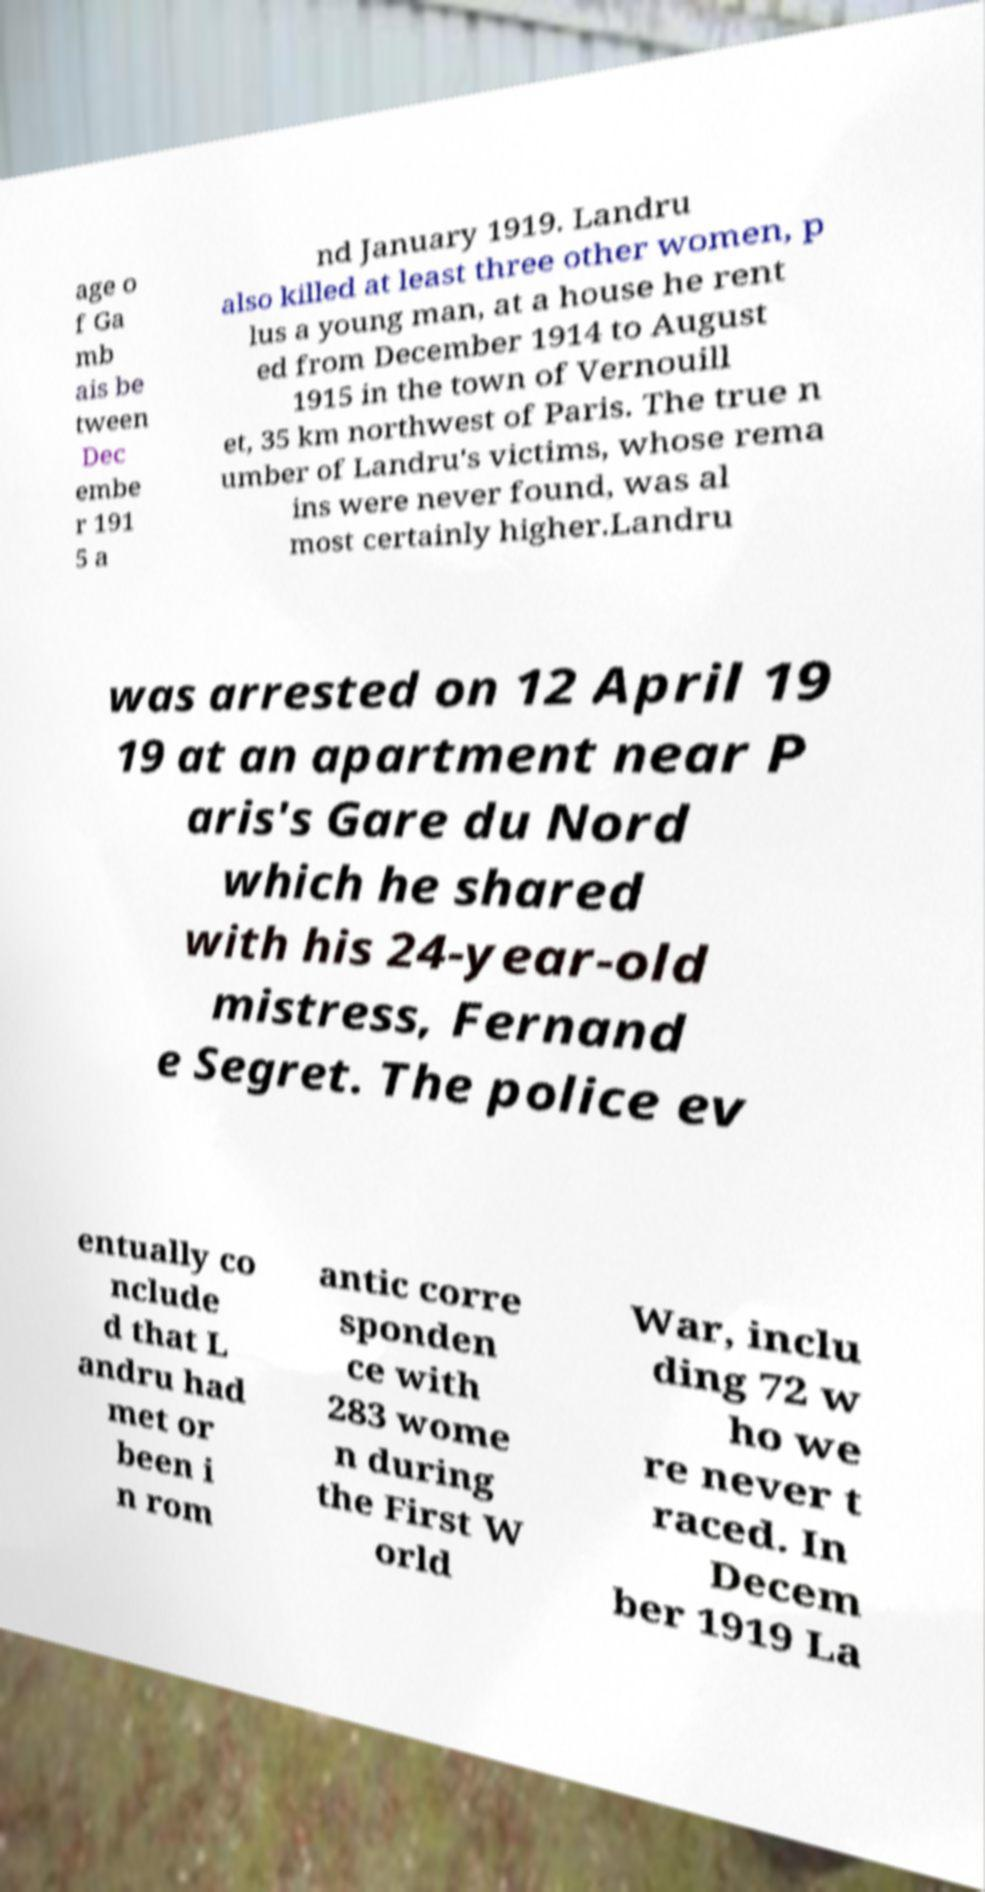What messages or text are displayed in this image? I need them in a readable, typed format. age o f Ga mb ais be tween Dec embe r 191 5 a nd January 1919. Landru also killed at least three other women, p lus a young man, at a house he rent ed from December 1914 to August 1915 in the town of Vernouill et, 35 km northwest of Paris. The true n umber of Landru's victims, whose rema ins were never found, was al most certainly higher.Landru was arrested on 12 April 19 19 at an apartment near P aris's Gare du Nord which he shared with his 24-year-old mistress, Fernand e Segret. The police ev entually co nclude d that L andru had met or been i n rom antic corre sponden ce with 283 wome n during the First W orld War, inclu ding 72 w ho we re never t raced. In Decem ber 1919 La 